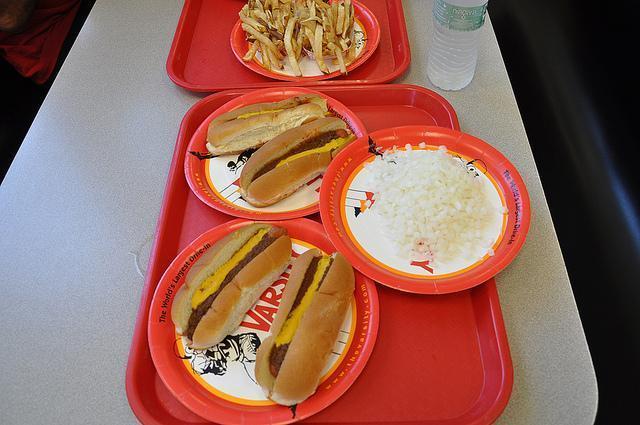How many food trays are there?
Give a very brief answer. 2. How many hot dogs are there?
Give a very brief answer. 4. 